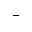Convert formula to latex. <formula><loc_0><loc_0><loc_500><loc_500>-</formula> 